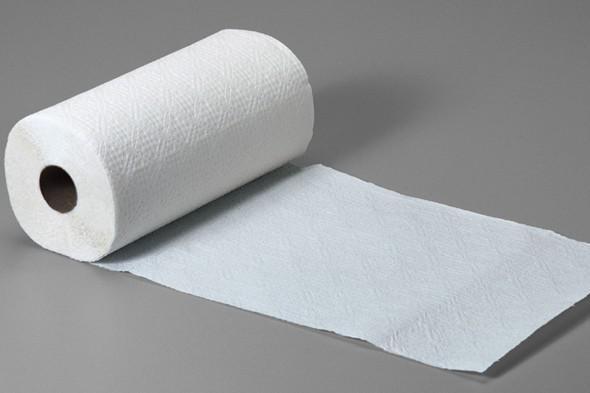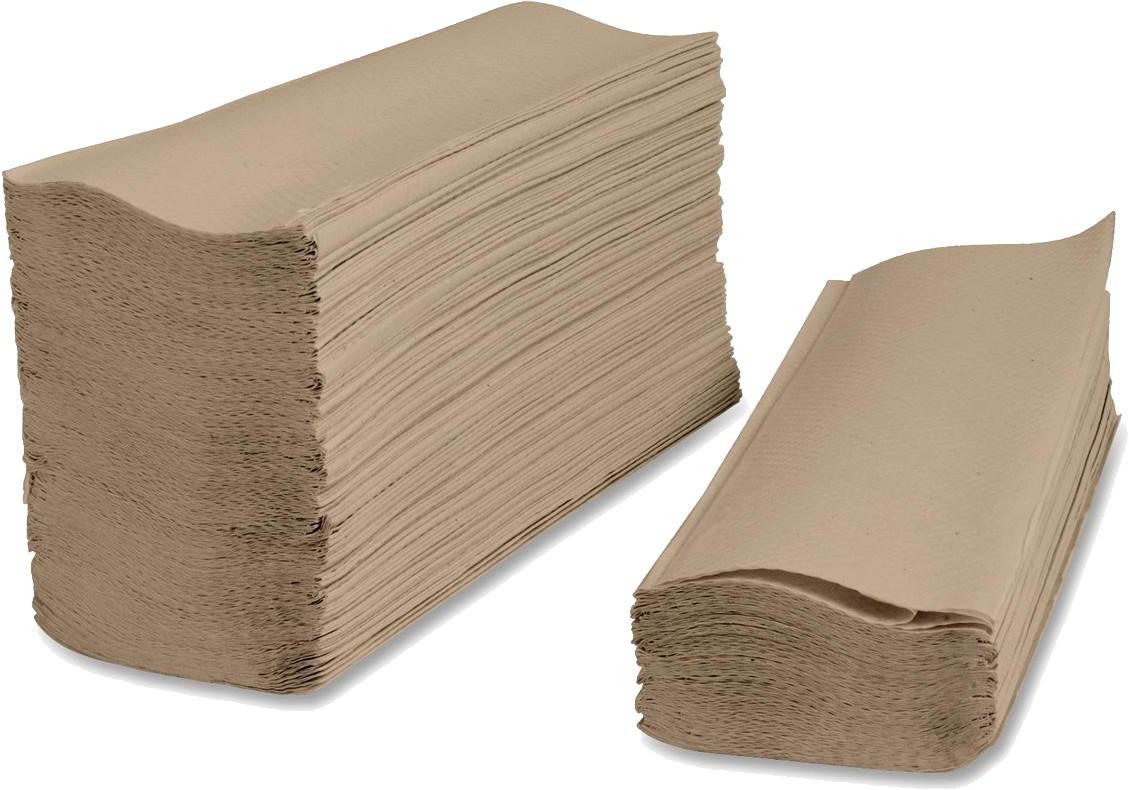The first image is the image on the left, the second image is the image on the right. Evaluate the accuracy of this statement regarding the images: "One of the images shows folded paper towels.". Is it true? Answer yes or no. Yes. The first image is the image on the left, the second image is the image on the right. Given the left and right images, does the statement "one of the images contains two stacks of paper towels." hold true? Answer yes or no. Yes. 